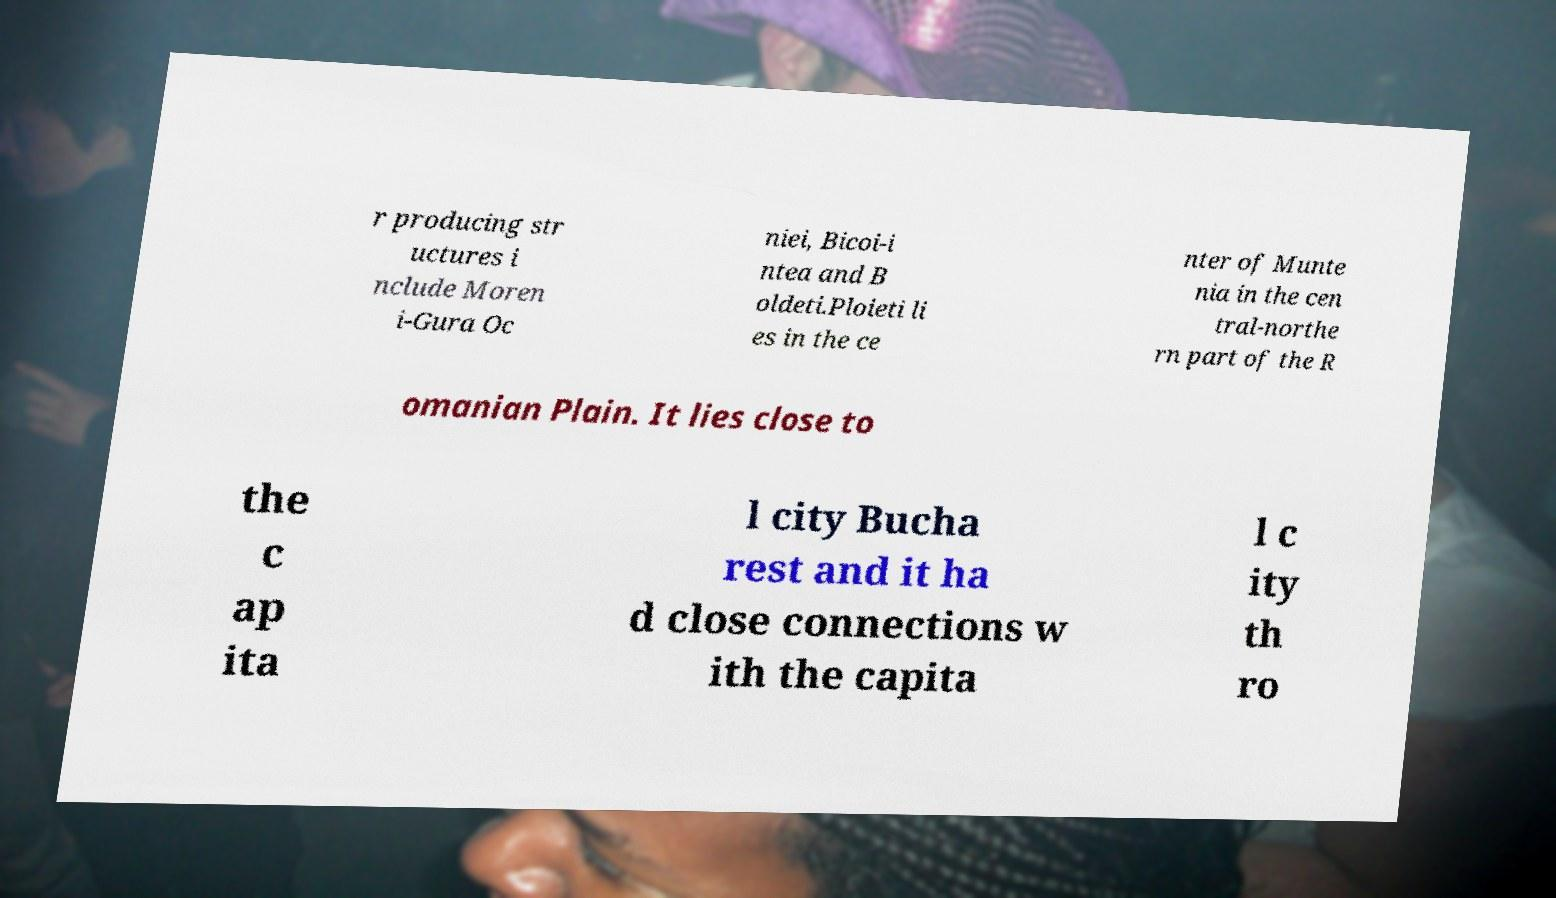For documentation purposes, I need the text within this image transcribed. Could you provide that? r producing str uctures i nclude Moren i-Gura Oc niei, Bicoi-i ntea and B oldeti.Ploieti li es in the ce nter of Munte nia in the cen tral-northe rn part of the R omanian Plain. It lies close to the c ap ita l city Bucha rest and it ha d close connections w ith the capita l c ity th ro 